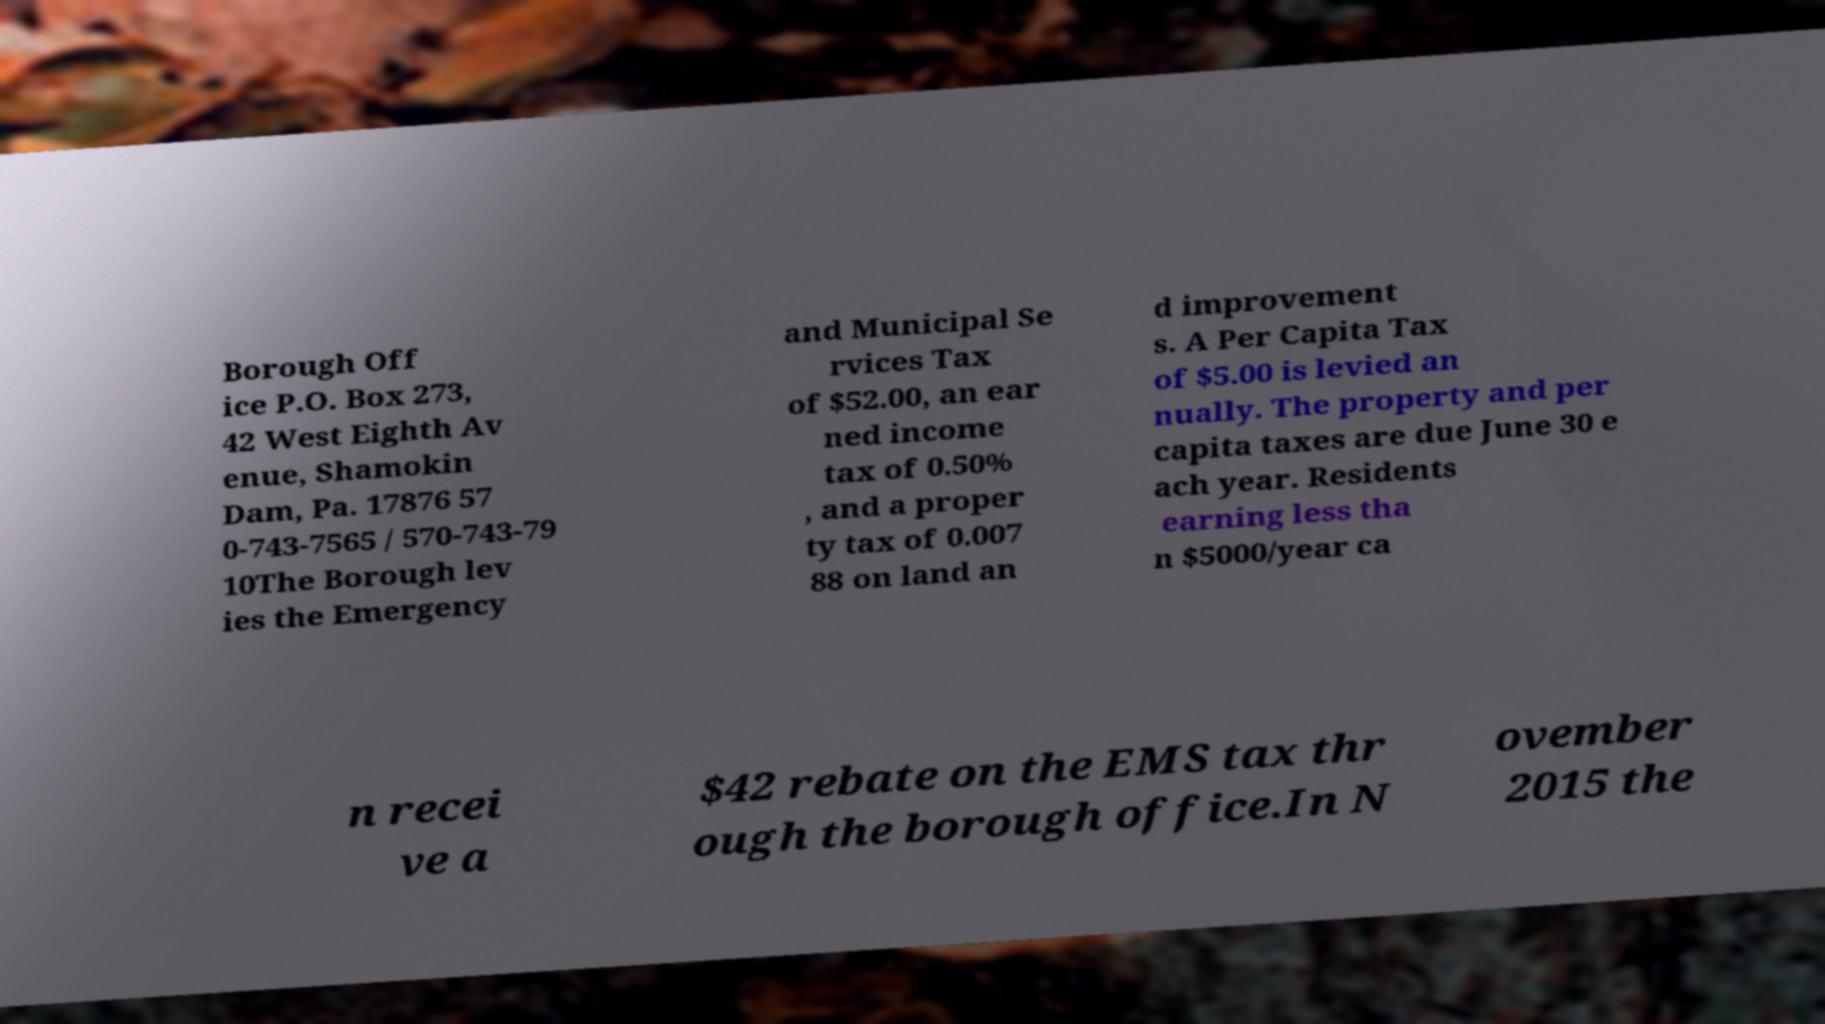Please identify and transcribe the text found in this image. Borough Off ice P.O. Box 273, 42 West Eighth Av enue, Shamokin Dam, Pa. 17876 57 0-743-7565 / 570-743-79 10The Borough lev ies the Emergency and Municipal Se rvices Tax of $52.00, an ear ned income tax of 0.50% , and a proper ty tax of 0.007 88 on land an d improvement s. A Per Capita Tax of $5.00 is levied an nually. The property and per capita taxes are due June 30 e ach year. Residents earning less tha n $5000/year ca n recei ve a $42 rebate on the EMS tax thr ough the borough office.In N ovember 2015 the 